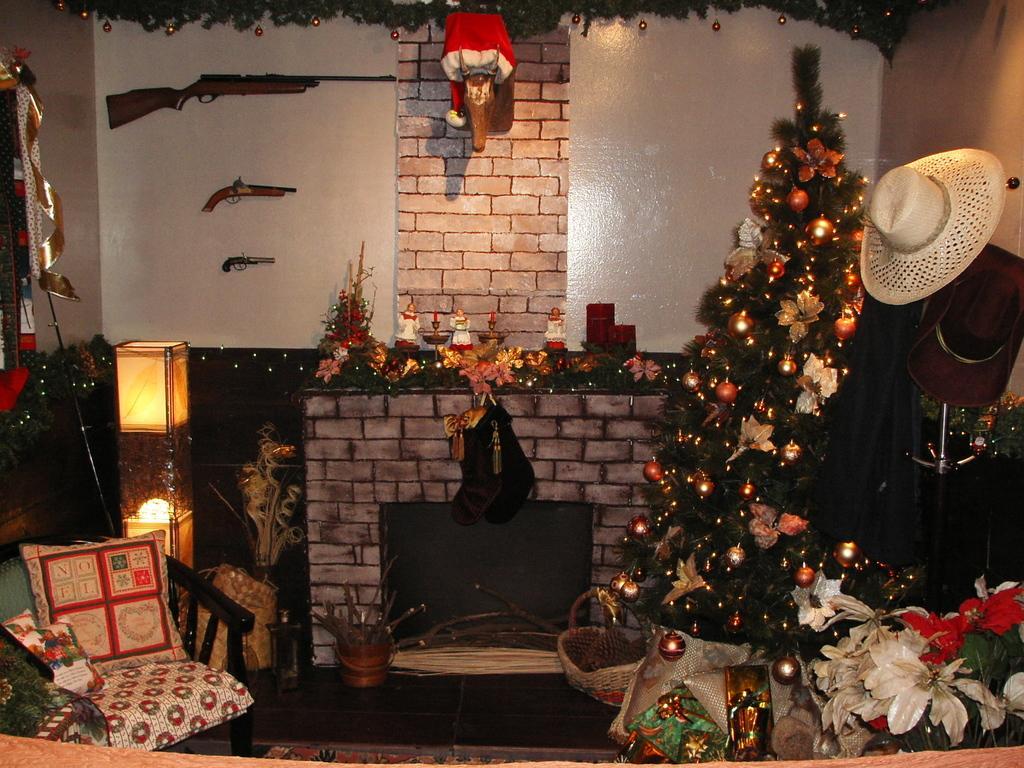Describe this image in one or two sentences. in a room there is a Christmas tree hat guns on the wall and the Santa Claus cap and a chair with a pillow on it lights and TV. 